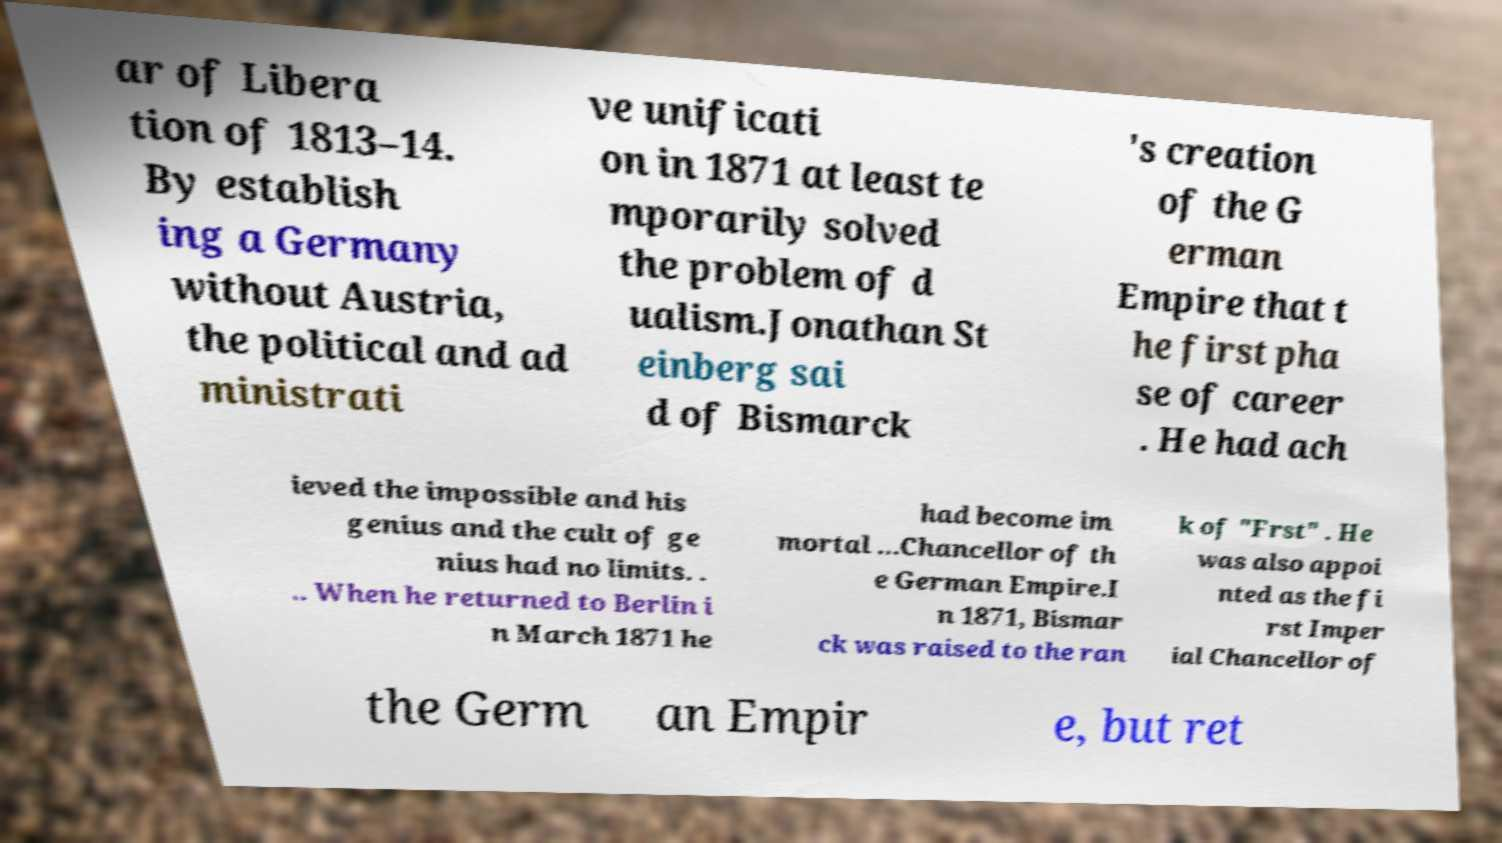Could you extract and type out the text from this image? ar of Libera tion of 1813–14. By establish ing a Germany without Austria, the political and ad ministrati ve unificati on in 1871 at least te mporarily solved the problem of d ualism.Jonathan St einberg sai d of Bismarck 's creation of the G erman Empire that t he first pha se of career . He had ach ieved the impossible and his genius and the cult of ge nius had no limits. . .. When he returned to Berlin i n March 1871 he had become im mortal ...Chancellor of th e German Empire.I n 1871, Bismar ck was raised to the ran k of "Frst" . He was also appoi nted as the fi rst Imper ial Chancellor of the Germ an Empir e, but ret 